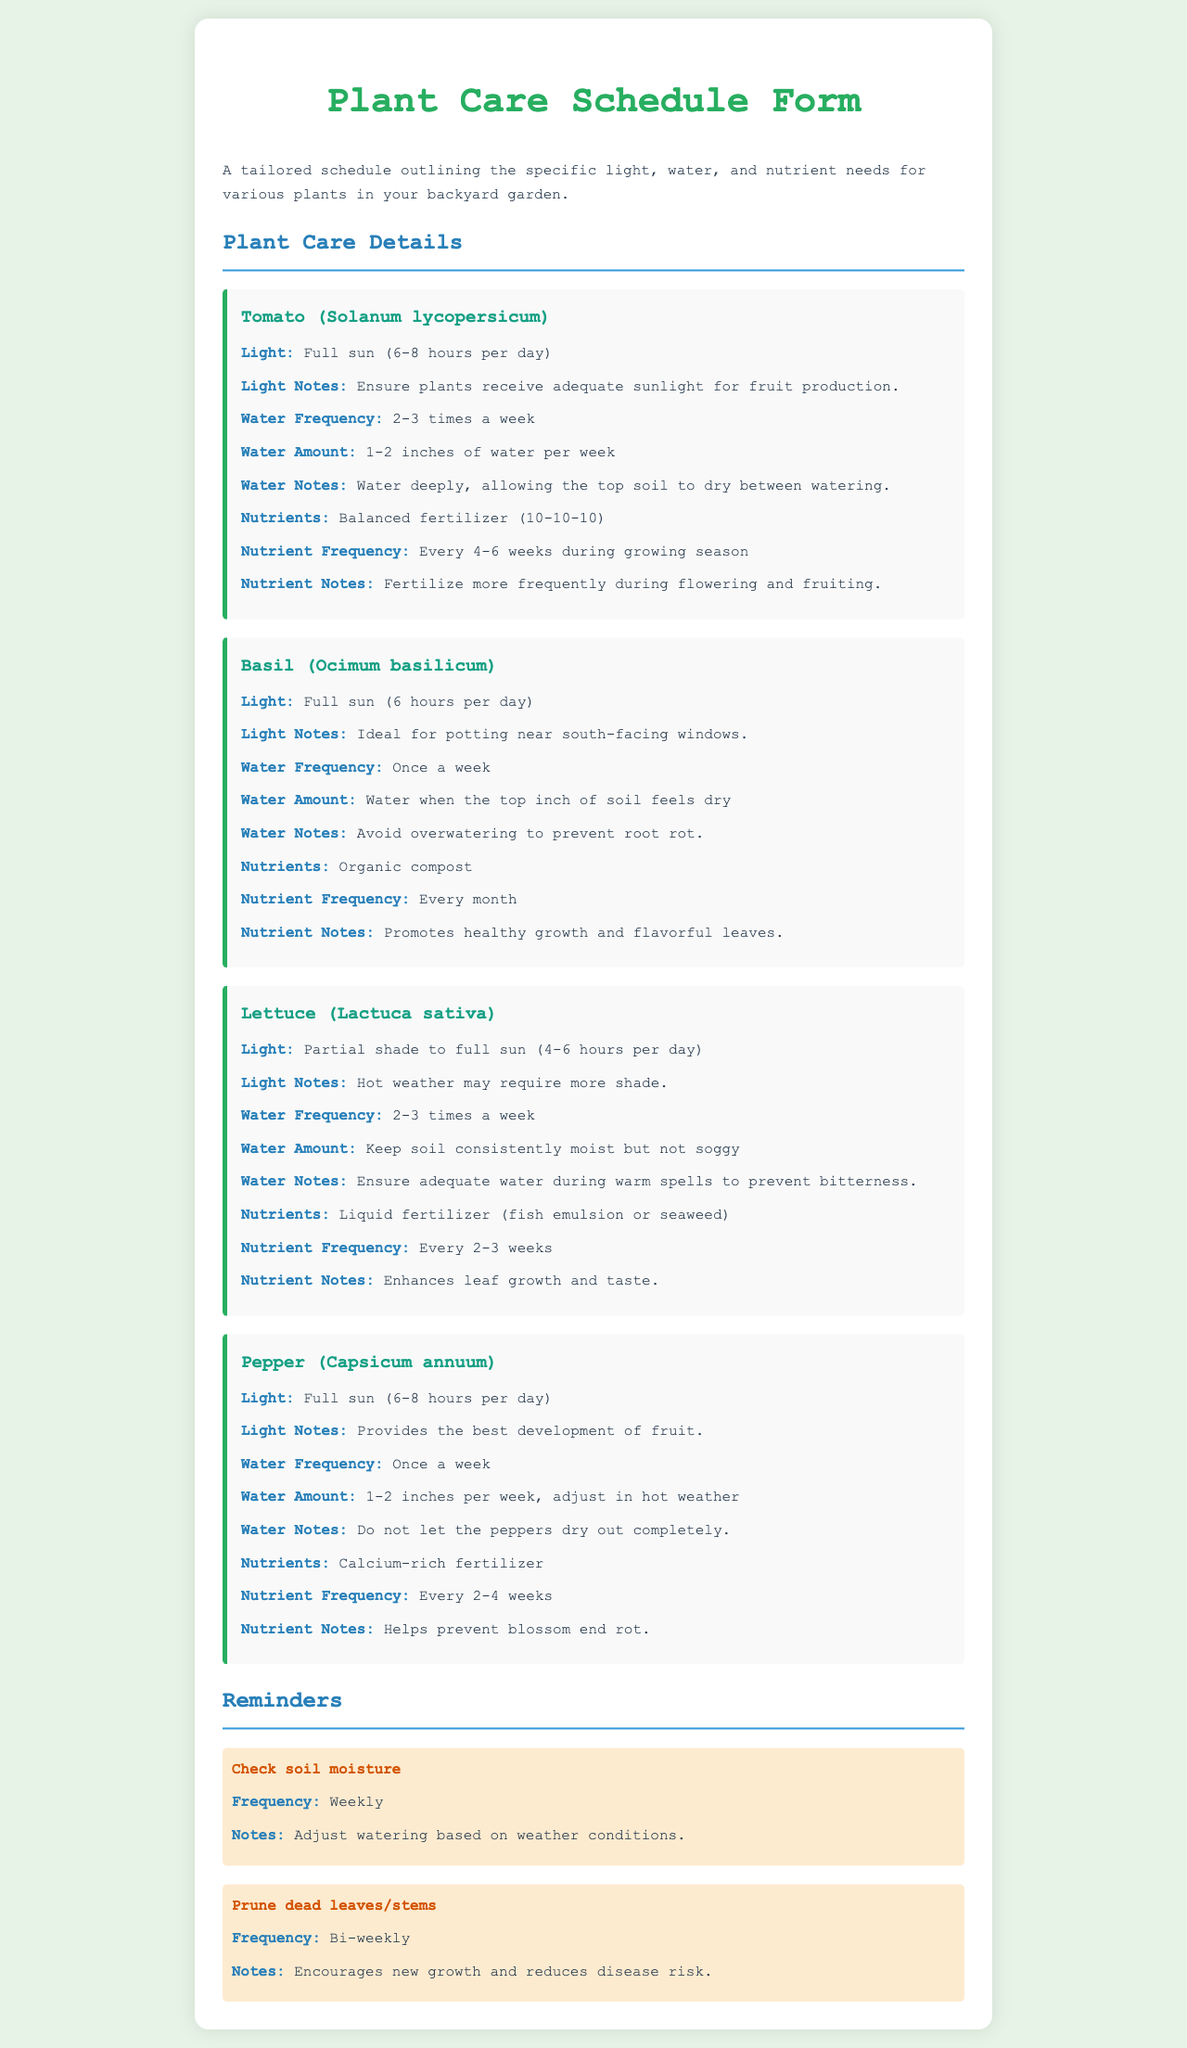What are the light requirements for Tomato? The document specifies that the Tomato plant needs full sun (6-8 hours per day).
Answer: Full sun (6-8 hours per day) How often should Basil be watered? According to the document, Basil should be watered once a week.
Answer: Once a week What is the nutrient frequency for Lettuce? The document indicates that Lettuce's nutrient frequency is every 2-3 weeks.
Answer: Every 2-3 weeks Which plant requires calcium-rich fertilizer? Per the document, the Pepper plant requires calcium-rich fertilizer.
Answer: Pepper What light condition is optimal for Basil? The document states that Basil is ideal for potting near south-facing windows, indicating preference for full sun.
Answer: Full sun What is the recommended water amount for Tomato? The document advises watering the Tomato with 1-2 inches of water per week.
Answer: 1-2 inches of water per week How frequently should dead leaves be pruned? The document specifies that dead leaves/stems should be pruned bi-weekly.
Answer: Bi-weekly What notes are provided for watering Lettuce? The document mentions that Lettuce should keep soil consistently moist but not soggy.
Answer: Keep soil consistently moist but not soggy What is a reminder provided in the document? The document includes reminders like checking soil moisture weekly and pruning dead leaves bi-weekly.
Answer: Check soil moisture, prune dead leaves 